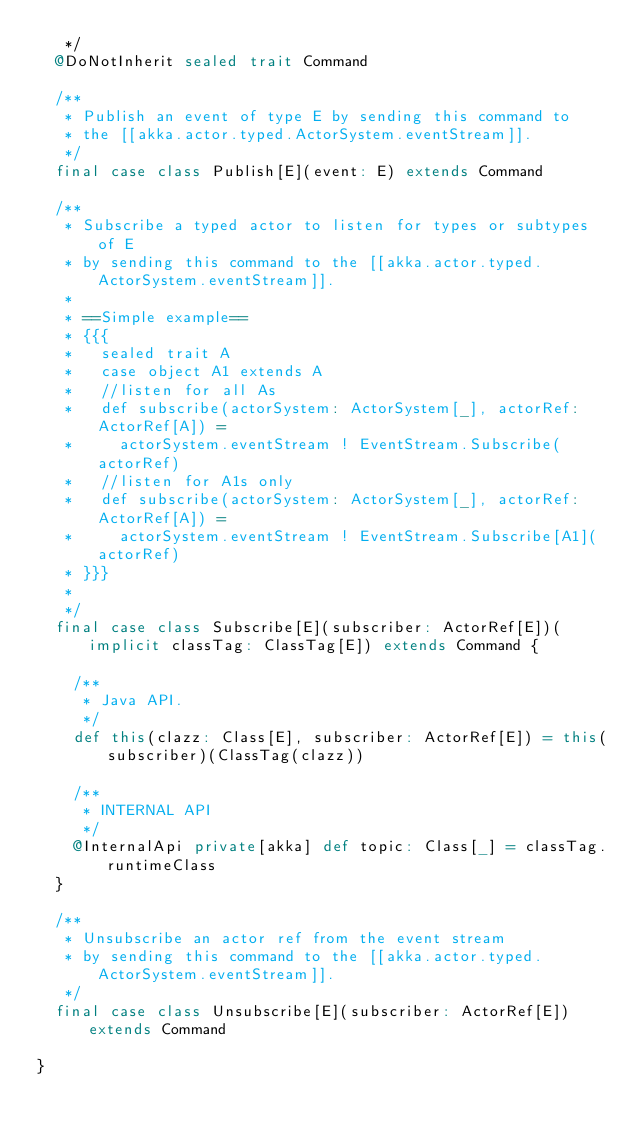Convert code to text. <code><loc_0><loc_0><loc_500><loc_500><_Scala_>   */
  @DoNotInherit sealed trait Command

  /**
   * Publish an event of type E by sending this command to
   * the [[akka.actor.typed.ActorSystem.eventStream]].
   */
  final case class Publish[E](event: E) extends Command

  /**
   * Subscribe a typed actor to listen for types or subtypes of E
   * by sending this command to the [[akka.actor.typed.ActorSystem.eventStream]].
   *
   * ==Simple example==
   * {{{
   *   sealed trait A
   *   case object A1 extends A
   *   //listen for all As
   *   def subscribe(actorSystem: ActorSystem[_], actorRef: ActorRef[A]) =
   *     actorSystem.eventStream ! EventStream.Subscribe(actorRef)
   *   //listen for A1s only
   *   def subscribe(actorSystem: ActorSystem[_], actorRef: ActorRef[A]) =
   *     actorSystem.eventStream ! EventStream.Subscribe[A1](actorRef)
   * }}}
   *
   */
  final case class Subscribe[E](subscriber: ActorRef[E])(implicit classTag: ClassTag[E]) extends Command {

    /**
     * Java API.
     */
    def this(clazz: Class[E], subscriber: ActorRef[E]) = this(subscriber)(ClassTag(clazz))

    /**
     * INTERNAL API
     */
    @InternalApi private[akka] def topic: Class[_] = classTag.runtimeClass
  }

  /**
   * Unsubscribe an actor ref from the event stream
   * by sending this command to the [[akka.actor.typed.ActorSystem.eventStream]].
   */
  final case class Unsubscribe[E](subscriber: ActorRef[E]) extends Command

}
</code> 